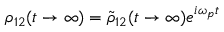<formula> <loc_0><loc_0><loc_500><loc_500>\rho _ { 1 2 } ( t \rightarrow \infty ) = \tilde { \rho } _ { 1 2 } ( t \rightarrow \infty ) e ^ { i \omega _ { p } t }</formula> 